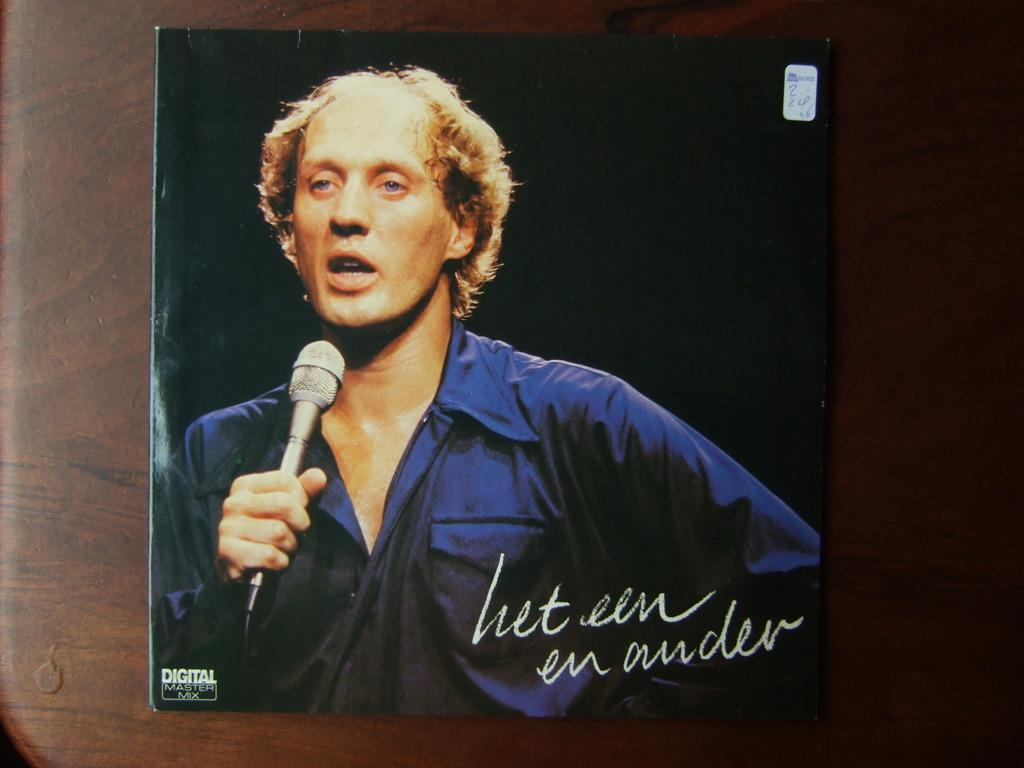What piece of furniture is present in the image? There is a table in the image. What is on top of the table? There is an object with text on it on the table. What is the person in the image doing? The person is standing in the image and talking while holding a mic. What type of dress is the person wearing in the image? There is no mention of a dress in the image, as the person is talking while holding a mic. Can you see a boat in the image? There is no boat present in the image. 